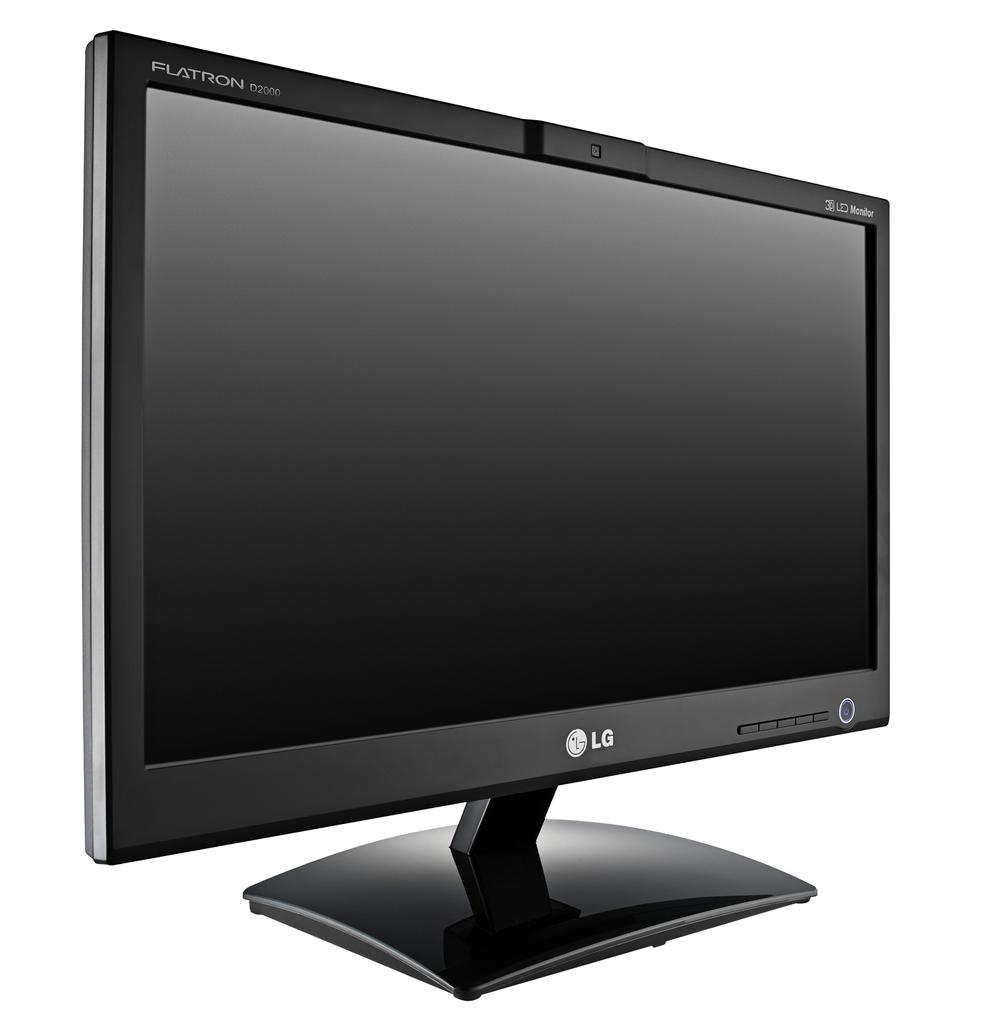<image>
Create a compact narrative representing the image presented. an LG flatron monitor is against a white background 